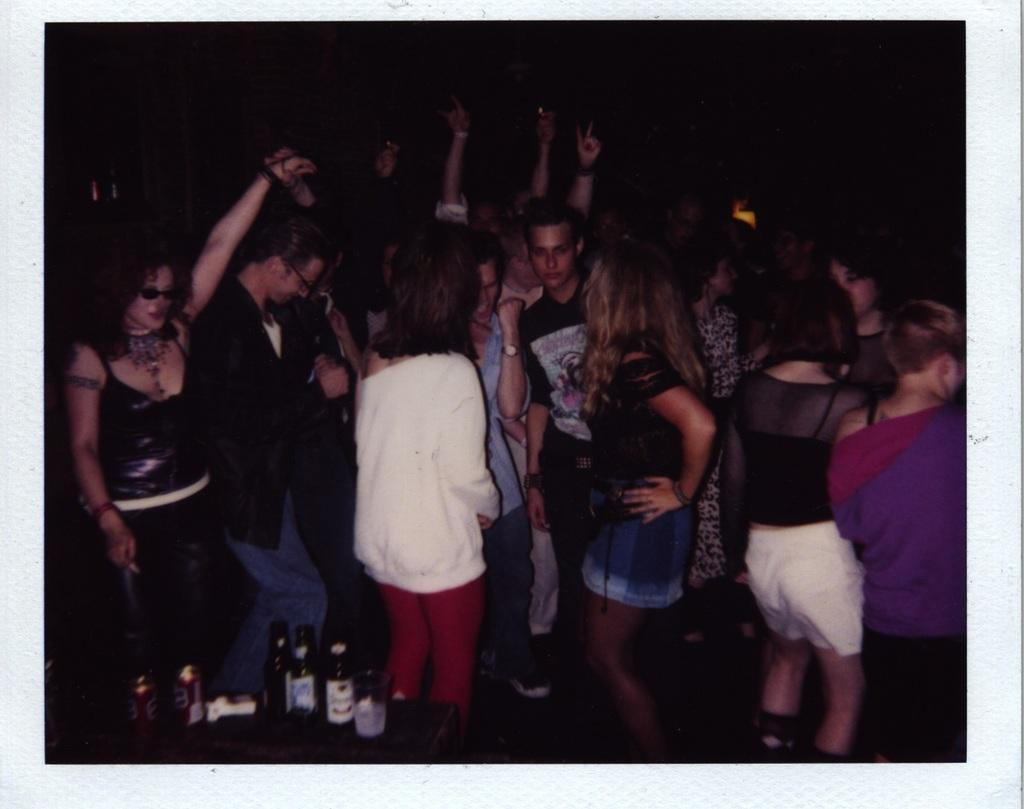How many people are in the group visible in the image? There is a group of people in the image. What are the people in the group doing? The people are dancing. What can be seen besides the people dancing in the image? There are wine bottles visible in the image. What type of flooring can be seen beneath the people dancing in the image? There is no specific information about the flooring in the image. How many children are present in the image? The provided facts do not mention any children in the image. 